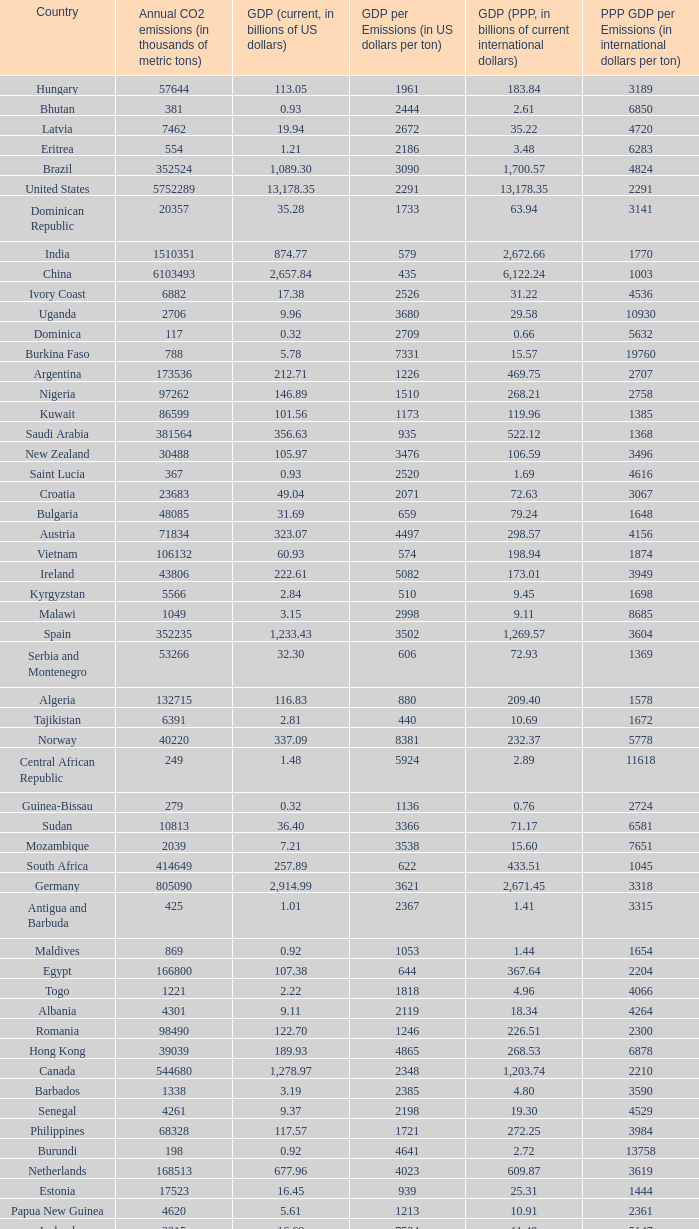When the gdp (ppp, in billions of current international dollars) is 7.93, what is the maximum ppp gdp per emissions (in international dollars per ton)? 9960.0. Parse the table in full. {'header': ['Country', 'Annual CO2 emissions (in thousands of metric tons)', 'GDP (current, in billions of US dollars)', 'GDP per Emissions (in US dollars per ton)', 'GDP (PPP, in billions of current international dollars)', 'PPP GDP per Emissions (in international dollars per ton)'], 'rows': [['Hungary', '57644', '113.05', '1961', '183.84', '3189'], ['Bhutan', '381', '0.93', '2444', '2.61', '6850'], ['Latvia', '7462', '19.94', '2672', '35.22', '4720'], ['Eritrea', '554', '1.21', '2186', '3.48', '6283'], ['Brazil', '352524', '1,089.30', '3090', '1,700.57', '4824'], ['United States', '5752289', '13,178.35', '2291', '13,178.35', '2291'], ['Dominican Republic', '20357', '35.28', '1733', '63.94', '3141'], ['India', '1510351', '874.77', '579', '2,672.66', '1770'], ['China', '6103493', '2,657.84', '435', '6,122.24', '1003'], ['Ivory Coast', '6882', '17.38', '2526', '31.22', '4536'], ['Uganda', '2706', '9.96', '3680', '29.58', '10930'], ['Dominica', '117', '0.32', '2709', '0.66', '5632'], ['Burkina Faso', '788', '5.78', '7331', '15.57', '19760'], ['Argentina', '173536', '212.71', '1226', '469.75', '2707'], ['Nigeria', '97262', '146.89', '1510', '268.21', '2758'], ['Kuwait', '86599', '101.56', '1173', '119.96', '1385'], ['Saudi Arabia', '381564', '356.63', '935', '522.12', '1368'], ['New Zealand', '30488', '105.97', '3476', '106.59', '3496'], ['Saint Lucia', '367', '0.93', '2520', '1.69', '4616'], ['Croatia', '23683', '49.04', '2071', '72.63', '3067'], ['Bulgaria', '48085', '31.69', '659', '79.24', '1648'], ['Austria', '71834', '323.07', '4497', '298.57', '4156'], ['Vietnam', '106132', '60.93', '574', '198.94', '1874'], ['Ireland', '43806', '222.61', '5082', '173.01', '3949'], ['Kyrgyzstan', '5566', '2.84', '510', '9.45', '1698'], ['Malawi', '1049', '3.15', '2998', '9.11', '8685'], ['Spain', '352235', '1,233.43', '3502', '1,269.57', '3604'], ['Serbia and Montenegro', '53266', '32.30', '606', '72.93', '1369'], ['Algeria', '132715', '116.83', '880', '209.40', '1578'], ['Tajikistan', '6391', '2.81', '440', '10.69', '1672'], ['Norway', '40220', '337.09', '8381', '232.37', '5778'], ['Central African Republic', '249', '1.48', '5924', '2.89', '11618'], ['Guinea-Bissau', '279', '0.32', '1136', '0.76', '2724'], ['Sudan', '10813', '36.40', '3366', '71.17', '6581'], ['Mozambique', '2039', '7.21', '3538', '15.60', '7651'], ['South Africa', '414649', '257.89', '622', '433.51', '1045'], ['Germany', '805090', '2,914.99', '3621', '2,671.45', '3318'], ['Antigua and Barbuda', '425', '1.01', '2367', '1.41', '3315'], ['Maldives', '869', '0.92', '1053', '1.44', '1654'], ['Egypt', '166800', '107.38', '644', '367.64', '2204'], ['Togo', '1221', '2.22', '1818', '4.96', '4066'], ['Albania', '4301', '9.11', '2119', '18.34', '4264'], ['Romania', '98490', '122.70', '1246', '226.51', '2300'], ['Hong Kong', '39039', '189.93', '4865', '268.53', '6878'], ['Canada', '544680', '1,278.97', '2348', '1,203.74', '2210'], ['Barbados', '1338', '3.19', '2385', '4.80', '3590'], ['Senegal', '4261', '9.37', '2198', '19.30', '4529'], ['Philippines', '68328', '117.57', '1721', '272.25', '3984'], ['Burundi', '198', '0.92', '4641', '2.72', '13758'], ['Netherlands', '168513', '677.96', '4023', '609.87', '3619'], ['Estonia', '17523', '16.45', '939', '25.31', '1444'], ['Papua New Guinea', '4620', '5.61', '1213', '10.91', '2361'], ['Iceland', '2215', '16.69', '7534', '11.40', '5147'], ['Belarus', '68849', '36.96', '537', '94.80', '1377'], ['Guyana', '1507', '0.91', '606', '2.70', '1792'], ['Nicaragua', '4334', '5.26', '1215', '14.93', '3444'], ['Chile', '60100', '146.76', '2442', '214.41', '3568'], ['Bangladesh', '41609', '65.20', '1567', '190.93', '4589'], ['Niger', '935', '3.65', '3903', '8.56', '9157'], ['Oman', '41378', '35.73', '863', '56.44', '1364'], ['Belgium', '107199', '400.30', '3734', '358.02', '3340'], ['Lithuania', '14190', '30.08', '2120', '54.04', '3808'], ['Venezuela', '171593', '184.25', '1074', '300.80', '1753'], ['Chad', '396', '6.31', '15924', '15.40', '38881'], ['Libya', '55495', '55.08', '992', '75.47', '1360'], ['Vanuatu', '92', '0.42', '4522', '0.83', '9065'], ['Laos', '1426', '3.51', '2459', '11.41', '8000'], ['Benin', '3109', '4.74', '1524', '11.29', '3631'], ['Sri Lanka', '11876', '28.28', '2381', '77.51', '6526'], ['Czech Republic', '116991', '142.31', '1216', '228.48', '1953'], ['Denmark', '53944', '274.11', '5081', '193.54', '3588'], ['Morocco', '45316', '65.64', '1448', '120.32', '2655'], ['Sweden', '50875', '393.76', '7740', '318.42', '6259'], ['Cyprus', '7788', '18.43', '2366', '19.99', '2566'], ['Israel', '70440', '143.98', '2044', '174.61', '2479'], ['Equatorial Guinea', '4356', '9.60', '2205', '15.76', '3618'], ['Mali', '568', '6.13', '10789', '13.10', '23055'], ['Namibia', '2831', '7.98', '2819', '11.98', '4230'], ['Belize', '818', '1.21', '1483', '2.31', '2823'], ['Seychelles', '744', '0.97', '1301', '1.61', '2157'], ['Saint Kitts and Nevis', '136', '0.49', '3588', '0.68', '4963'], ['South Korea', '475248', '952.03', '2003', '1,190.70', '2505'], ['Samoa', '158', '0.43', '2747', '0.95', '5987'], ['Honduras', '7194', '10.84', '1507', '28.20', '3920'], ['Turkmenistan', '44103', '21.40', '485', '23.40', '531'], ['Kenya', '12151', '22.52', '1853', '52.74', '4340'], ['Mauritius', '3850', '6.32', '1641', '13.09', '3399'], ['Madagascar', '2834', '5.52', '1947', '16.84', '5943'], ['Grenada', '242', '0.56', '2331', '1.05', '4331'], ['Burma', '10025', '14.50', '1447', '55.55', '5541'], ['Pakistan', '142659', '127.49', '894', '372.96', '2614'], ['Costa Rica', '7854', '22.53', '2868', '41.86', '5330'], ['Jordan', '20724', '14.84', '716', '26.25', '1266'], ['Comoros', '88', '0.40', '4591', '0.71', '8034'], ['Guinea', '1360', '2.90', '2135', '9.29', '6829'], ['Zimbabwe', '11081', '5.60', '505', '2.29', '207'], ['United Kingdom', '568520', '2,435.70', '4284', '2,048.99', '3604'], ['Suriname', '2438', '2.14', '878', '3.76', '1543'], ['Swaziland', '1016', '2.67', '2629', '5.18', '5095'], ['Switzerland', '41826', '388.68', '9293', '283.84', '6786'], ['United Arab Emirates', '139553', '164.17', '1176', '154.35', '1106'], ['Mauritania', '1665', '2.70', '1621', '5.74', '3448'], ['Syria', '68460', '33.51', '489', '82.09', '1199'], ['Panama', '6428', '17.13', '2666', '30.21', '4700'], ['Solomon Islands', '180', '0.33', '1856', '0.86', '4789'], ['Cambodia', '4074', '7.26', '1783', '23.03', '5653'], ['Sierra Leone', '994', '1.42', '1433', '3.62', '3644'], ['Kiribati', '29', '0.11', '3690', '0.56', '19448'], ['Gambia', '334', '0.51', '1521', '1.92', '5743'], ['Russia', '1564669', '989.43', '632', '1,887.61', '1206'], ['Angola', '10582', '45.17', '4268', '73.45', '6941'], ['Qatar', '46193', '56.92', '1232', '66.90', '1448'], ['Singapore', '56217', '139.18', '2476', '208.75', '3713'], ['Azerbaijan', '35050', '21.03', '600', '51.71', '1475'], ['Democratic Republic of the Congo', '2200', '8.79', '3993', '17.43', '7924'], ['Ethiopia', '6006', '15.17', '2525', '54.39', '9055'], ['Afghanistan', '697', '7.72', '11080', '17.56', '25187'], ['Ukraine', '319158', '108.00', '338', '291.30', '913'], ['Bahrain', '21292', '15.85', '744', '22.41', '1053'], ['Uruguay', '6864', '20.00', '2914', '34.60', '5041'], ['Saint Vincent and the Grenadines', '198', '0.50', '2515', '0.96', '4843'], ['Malaysia', '187865', '156.86', '835', '328.97', '1751'], ['Paraguay', '3986', '9.28', '2327', '24.81', '6224'], ['Slovakia', '37459', '56.00', '1495', '96.76', '2583'], ['Kazakhstan', '193508', '81.00', '419', '150.56', '778'], ['Guatemala', '11766', '30.26', '2572', '57.77', '4910'], ['Colombia', '63422', '162.50', '2562', '342.77', '5405'], ['El Salvador', '6461', '18.65', '2887', '38.79', '6004'], ['Bolivia', '6973', '11.53', '1653', '37.37', '5359'], ['São Tomé and Príncipe', '103', '0.13', '1214', '0.24', '2311'], ['Jamaica', '12151', '11.45', '942', '19.93', '1640'], ['Iran', '466976', '222.13', '476', '693.32', '1485'], ['European Union', '3908662', '14,510.82', '3712', '13,641.22', '3490'], ['Ecuador', '31328', '41.40', '1322', '94.48', '3016'], ['Trinidad and Tobago', '33601', '19.38', '577', '23.62', '703'], ['Gabon', '2057', '9.55', '4641', '18.63', '9057'], ['Poland', '318219', '341.67', '1074', '567.94', '1785'], ['Fiji', '1610', '3.17', '1967', '3.74', '2320'], ['Malta', '2548', '6.44', '2528', '8.88', '3485'], ['Luxembourg', '11277', '42.59', '3777', '36.02', '3194'], ['Tonga', '132', '0.24', '1788', '0.54', '4076'], ['Timor-Leste', '176', '0.33', '1858', '1.96', '11153'], ['Finland', '66693', '209.71', '3144', '172.98', '2594'], ['Djibouti', '488', '0.77', '1576', '1.61', '3297'], ['Liberia', '785', '0.61', '780', '1.19', '1520'], ['Republic of the Congo', '1463', '7.74', '5289', '13.10', '8954'], ['Iraq', '92572', '49.27', '532', '90.51', '978'], ['Cape Verde', '308', '1.20', '3906', '1.47', '4776'], ['Lebanon', '15330', '22.44', '1464', '40.46', '2639'], ['Portugal', '60001', '195.19', '3253', '220.57', '3676'], ['Thailand', '272521', '206.99', '760', '483.56', '1774'], ['Turkey', '269452', '529.19', '1964', '824.58', '3060'], ['Botswana', '4770', '11.30', '2369', '23.51', '4929'], ['Zambia', '2471', '10.89', '4408', '14.74', '5965'], ['Mexico', '436150', '952.34', '2184', '1,408.81', '3230'], ['Mongolia', '9442', '3.16', '334', '7.47', '791'], ['Cameroon', '3645', '17.96', '4926', '37.14', '10189'], ['Tunisia', '23126', '31.11', '1345', '70.57', '3052'], ['Ghana', '9240', '12.73', '1378', '28.72', '3108'], ['Macedonia', '10875', '6.38', '587', '16.14', '1484'], ['Yemen', '21201', '19.06', '899', '49.21', '2321'], ['Bosnia and Herzegovina', '27438', '12.28', '447', '25.70', '937'], ['Tanzania', '5372', '14.35', '2671', '44.46', '8276'], ['Slovenia', '15173', '38.94', '2566', '51.14', '3370'], ['Georgia', '5518', '7.77', '1408', '17.77', '3221'], ['Bahamas', '2138', '6.88', '3216', '8.67', '4053'], ['Moldova', '7821', '3.41', '436', '9.19', '1175'], ['Indonesia', '333483', '364.35', '1093', '767.92', '2303'], ['Armenia', '4371', '6.38', '1461', '14.68', '3357'], ['Brunei', '5911', '11.47', '1940', '18.93', '3203'], ['Nepal', '3241', '9.03', '2787', '27.86', '8595'], ['Haiti', '1811', '4.84', '2670', '10.52', '5809'], ['Rwanda', '796', '2.83', '3559', '7.93', '9960'], ['Australia', '372013', '755.21', '2030', '713.96', '1919'], ['Peru', '38643', '92.31', '2389', '195.99', '5072'], ['Italy', '474148', '1,865.11', '3934', '1,720.64', '3629'], ['Greece', '96382', '267.71', '2778', '303.60', '3150'], ['France', '383148', '2,271.28', '5928', '1,974.39', '5153'], ['Japan', '1293409', '4,363.63', '3374', '4,079.14', '3154']]} 